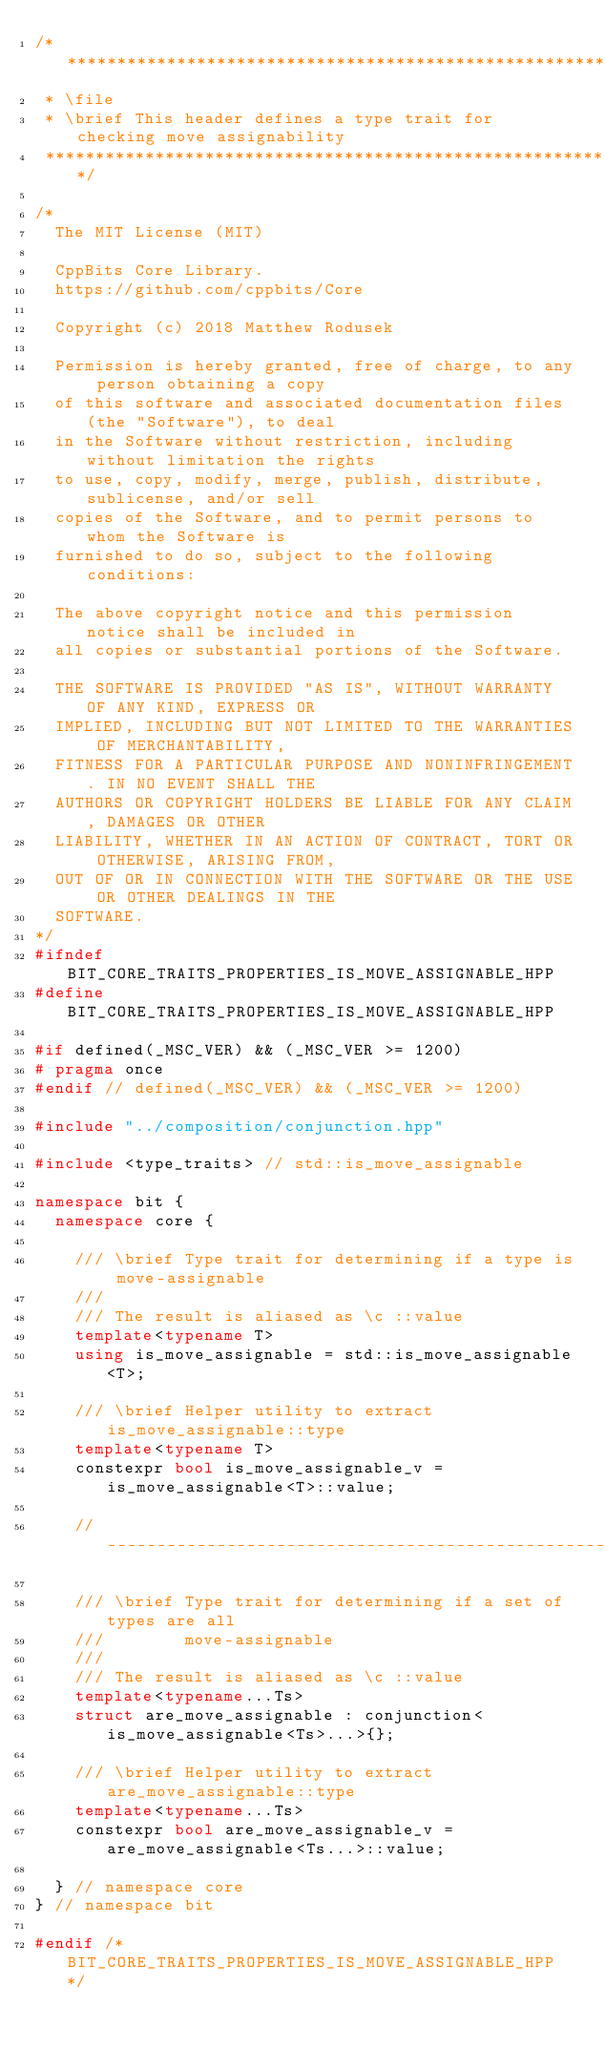Convert code to text. <code><loc_0><loc_0><loc_500><loc_500><_C++_>/*****************************************************************************
 * \file
 * \brief This header defines a type trait for checking move assignability
 *****************************************************************************/

/*
  The MIT License (MIT)

  CppBits Core Library.
  https://github.com/cppbits/Core

  Copyright (c) 2018 Matthew Rodusek

  Permission is hereby granted, free of charge, to any person obtaining a copy
  of this software and associated documentation files (the "Software"), to deal
  in the Software without restriction, including without limitation the rights
  to use, copy, modify, merge, publish, distribute, sublicense, and/or sell
  copies of the Software, and to permit persons to whom the Software is
  furnished to do so, subject to the following conditions:

  The above copyright notice and this permission notice shall be included in
  all copies or substantial portions of the Software.

  THE SOFTWARE IS PROVIDED "AS IS", WITHOUT WARRANTY OF ANY KIND, EXPRESS OR
  IMPLIED, INCLUDING BUT NOT LIMITED TO THE WARRANTIES OF MERCHANTABILITY,
  FITNESS FOR A PARTICULAR PURPOSE AND NONINFRINGEMENT. IN NO EVENT SHALL THE
  AUTHORS OR COPYRIGHT HOLDERS BE LIABLE FOR ANY CLAIM, DAMAGES OR OTHER
  LIABILITY, WHETHER IN AN ACTION OF CONTRACT, TORT OR OTHERWISE, ARISING FROM,
  OUT OF OR IN CONNECTION WITH THE SOFTWARE OR THE USE OR OTHER DEALINGS IN THE
  SOFTWARE.
*/
#ifndef BIT_CORE_TRAITS_PROPERTIES_IS_MOVE_ASSIGNABLE_HPP
#define BIT_CORE_TRAITS_PROPERTIES_IS_MOVE_ASSIGNABLE_HPP

#if defined(_MSC_VER) && (_MSC_VER >= 1200)
# pragma once
#endif // defined(_MSC_VER) && (_MSC_VER >= 1200)

#include "../composition/conjunction.hpp"

#include <type_traits> // std::is_move_assignable

namespace bit {
  namespace core {

    /// \brief Type trait for determining if a type is move-assignable
    ///
    /// The result is aliased as \c ::value
    template<typename T>
    using is_move_assignable = std::is_move_assignable<T>;

    /// \brief Helper utility to extract is_move_assignable::type
    template<typename T>
    constexpr bool is_move_assignable_v = is_move_assignable<T>::value;

    //-------------------------------------------------------------------------

    /// \brief Type trait for determining if a set of types are all
    ///        move-assignable
    ///
    /// The result is aliased as \c ::value
    template<typename...Ts>
    struct are_move_assignable : conjunction<is_move_assignable<Ts>...>{};

    /// \brief Helper utility to extract are_move_assignable::type
    template<typename...Ts>
    constexpr bool are_move_assignable_v = are_move_assignable<Ts...>::value;

  } // namespace core
} // namespace bit

#endif /* BIT_CORE_TRAITS_PROPERTIES_IS_MOVE_ASSIGNABLE_HPP */
</code> 